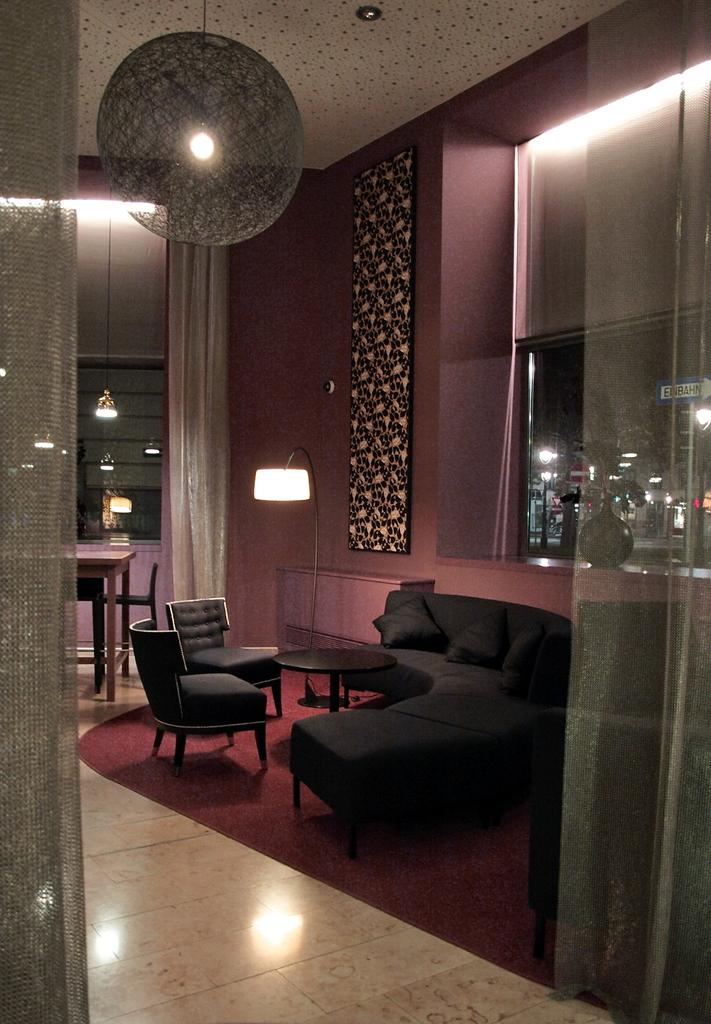What is the main piece of furniture in the middle of the image? There is a black color sofa in the middle of the image. What colors are used on the walls in the image? The walls in the image have light and dark red colors. Can you see any source of light in the image? Yes, there is a light visible in the image. What trick is the sofa attempting to perform in the image? The sofa is not attempting to perform any trick in the image; it is simply a piece of furniture. 